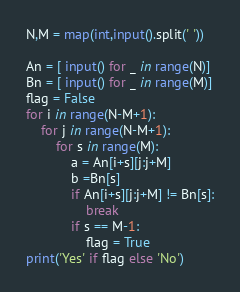<code> <loc_0><loc_0><loc_500><loc_500><_Python_>N,M = map(int,input().split(' '))

An = [ input() for _ in range(N)]
Bn = [ input() for _ in range(M)]
flag = False
for i in range(N-M+1):
    for j in range(N-M+1):
        for s in range(M):
            a = An[i+s][j:j+M]
            b =Bn[s]
            if An[i+s][j:j+M] != Bn[s]:
                break
            if s == M-1:
                flag = True
print('Yes' if flag else 'No')</code> 